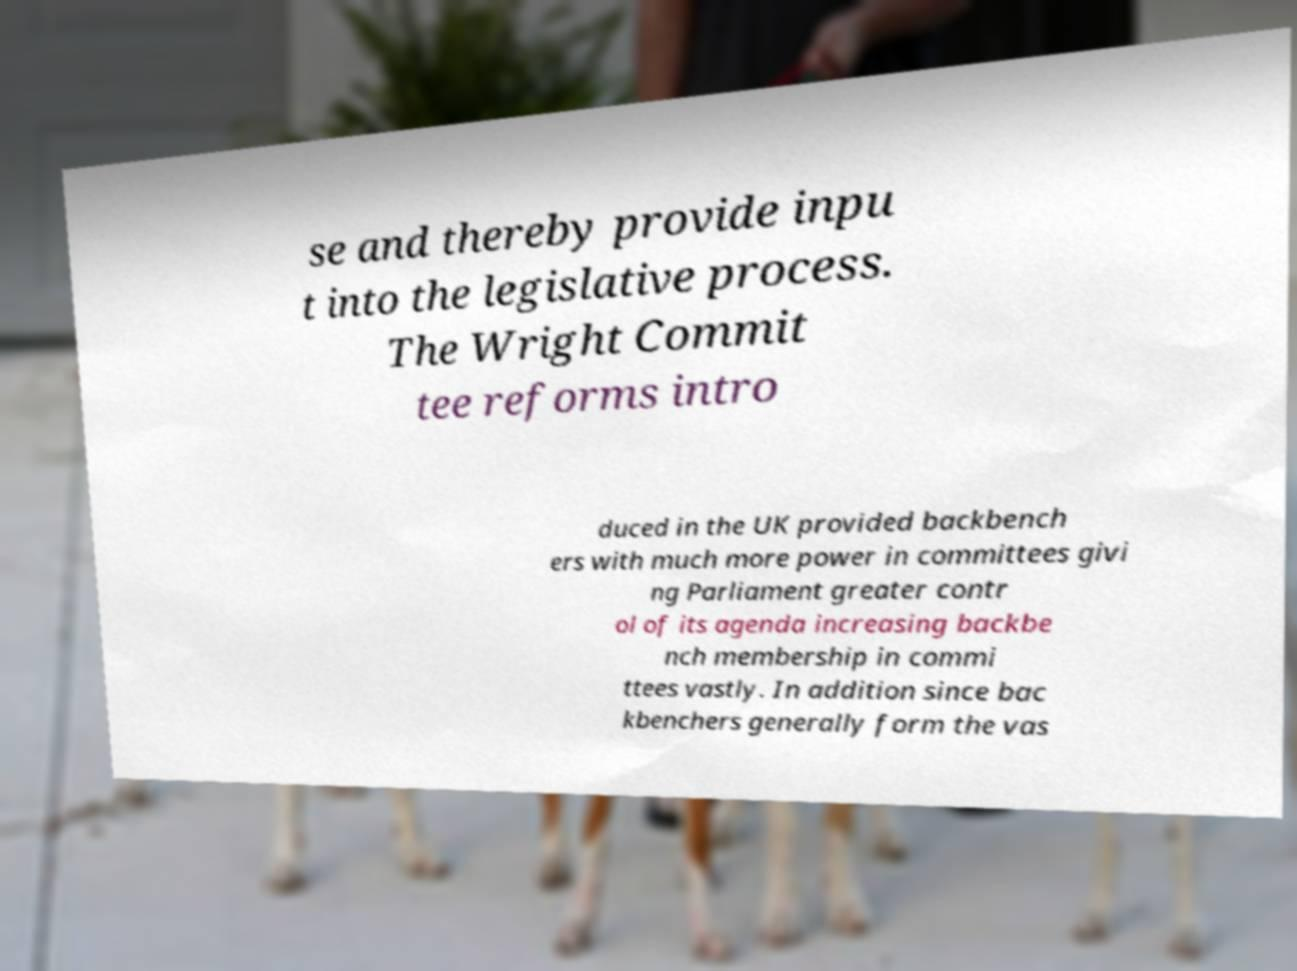Could you assist in decoding the text presented in this image and type it out clearly? se and thereby provide inpu t into the legislative process. The Wright Commit tee reforms intro duced in the UK provided backbench ers with much more power in committees givi ng Parliament greater contr ol of its agenda increasing backbe nch membership in commi ttees vastly. In addition since bac kbenchers generally form the vas 